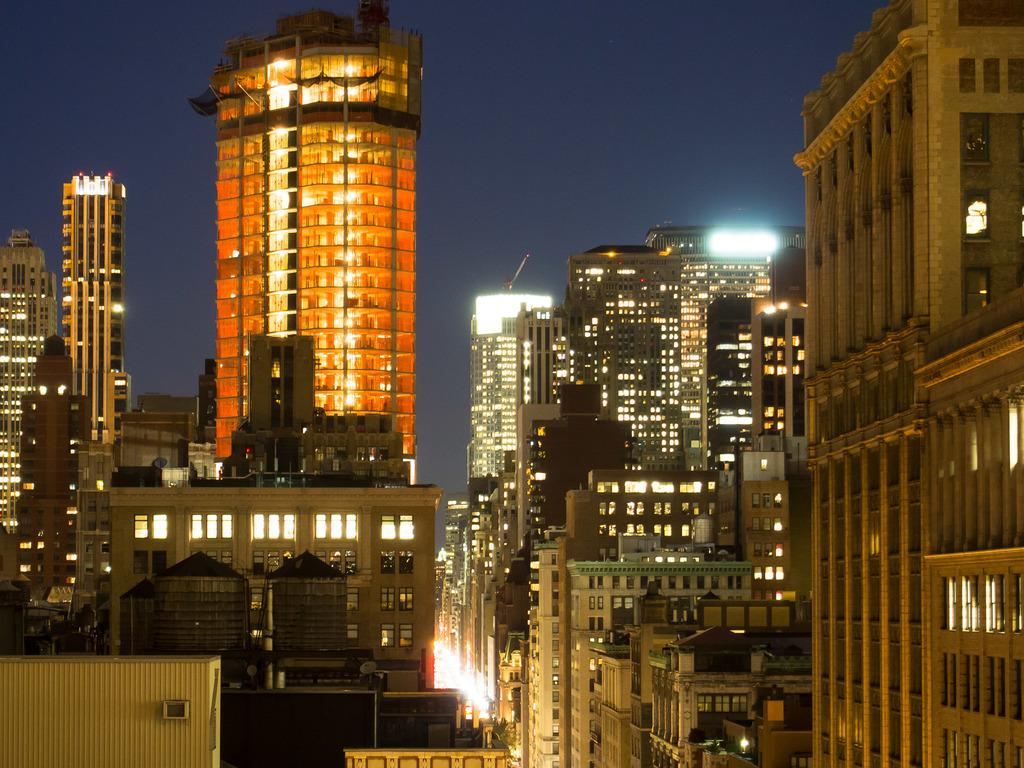What type of structures can be seen in the picture? There are buildings in the picture. Can you describe any specific features of the buildings? The buildings have lights in them. What type of trousers are hanging on the swing in the picture? There is no swing or trousers present in the picture; it only features buildings with lights. 